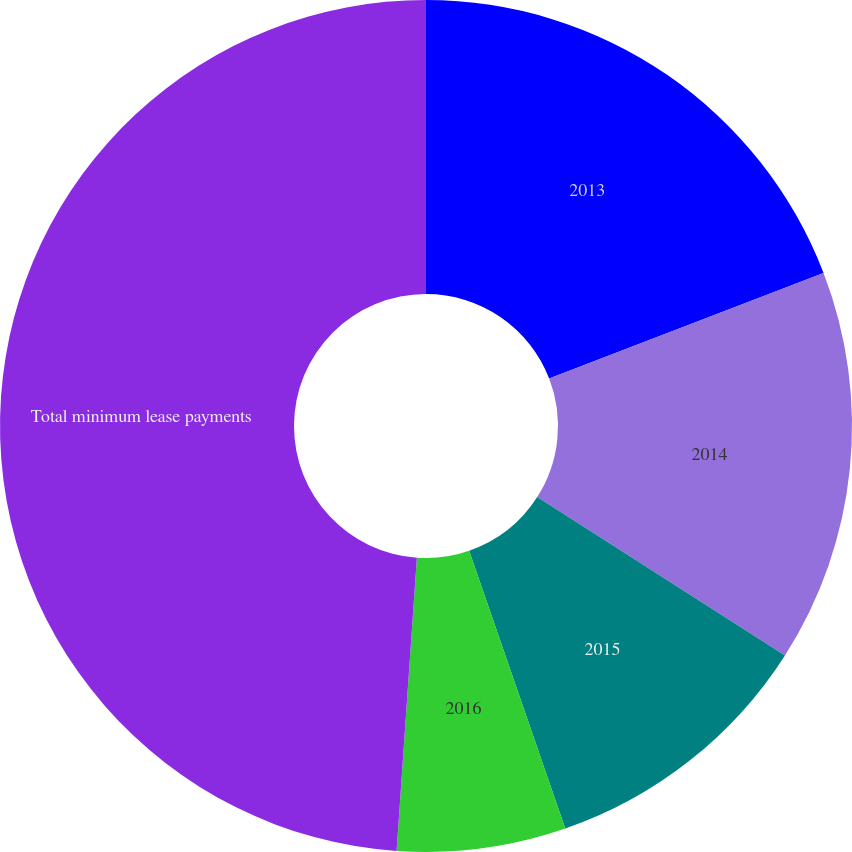<chart> <loc_0><loc_0><loc_500><loc_500><pie_chart><fcel>2013<fcel>2014<fcel>2015<fcel>2016<fcel>Total minimum lease payments<nl><fcel>19.15%<fcel>14.9%<fcel>10.65%<fcel>6.4%<fcel>48.9%<nl></chart> 